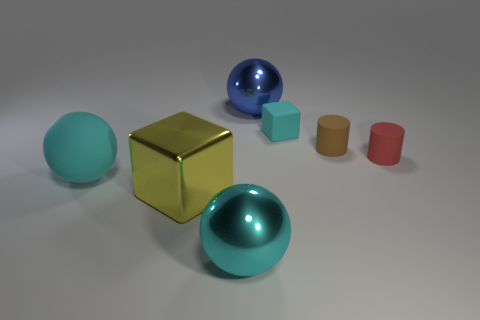Add 2 tiny gray spheres. How many objects exist? 9 Subtract all cubes. How many objects are left? 5 Subtract all metal spheres. Subtract all large metal objects. How many objects are left? 2 Add 4 large cyan shiny things. How many large cyan shiny things are left? 5 Add 7 small cyan cylinders. How many small cyan cylinders exist? 7 Subtract 0 yellow balls. How many objects are left? 7 